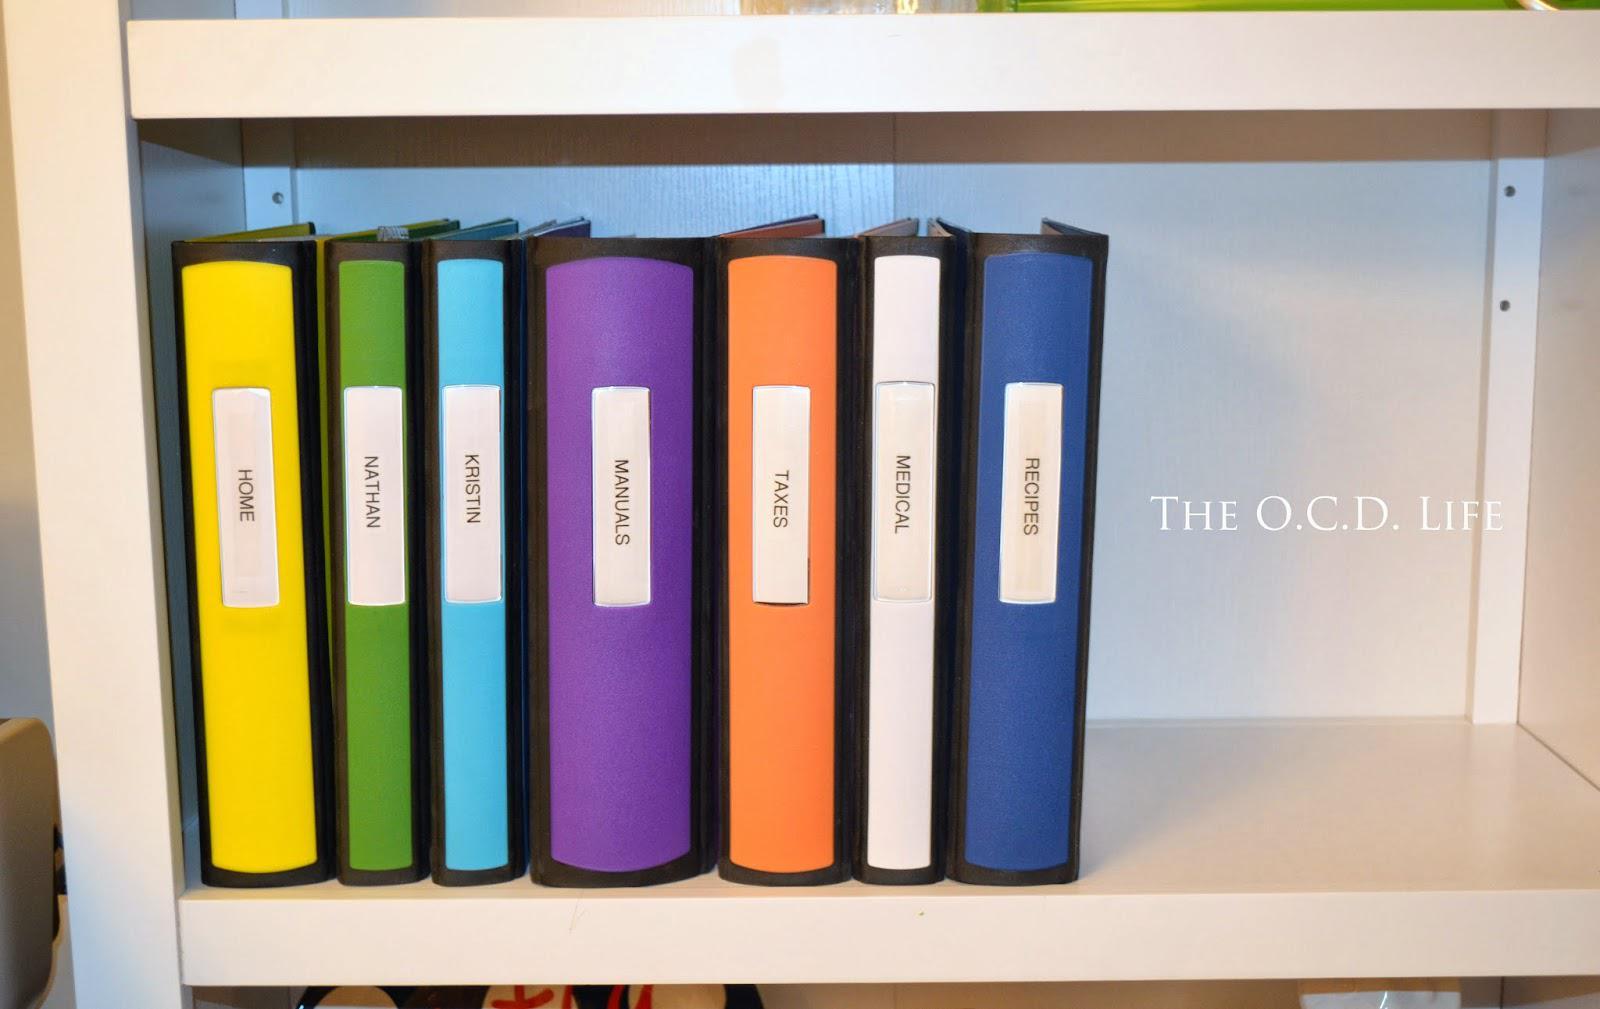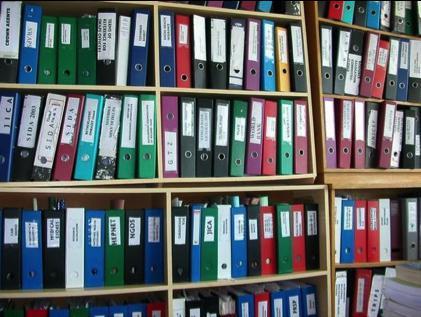The first image is the image on the left, the second image is the image on the right. Considering the images on both sides, is "there are no more than seven binders in one of the images" valid? Answer yes or no. Yes. The first image is the image on the left, the second image is the image on the right. Evaluate the accuracy of this statement regarding the images: "An image shows one row of colored folders with rectangular white labels on the binding.". Is it true? Answer yes or no. Yes. 